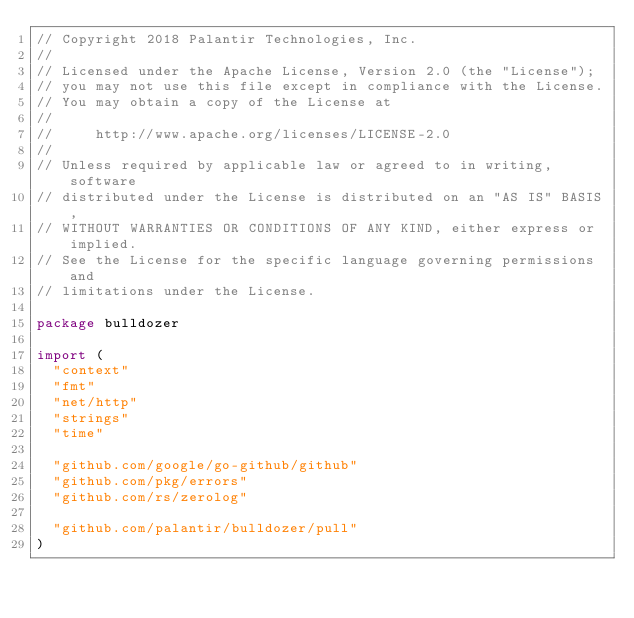<code> <loc_0><loc_0><loc_500><loc_500><_Go_>// Copyright 2018 Palantir Technologies, Inc.
//
// Licensed under the Apache License, Version 2.0 (the "License");
// you may not use this file except in compliance with the License.
// You may obtain a copy of the License at
//
//     http://www.apache.org/licenses/LICENSE-2.0
//
// Unless required by applicable law or agreed to in writing, software
// distributed under the License is distributed on an "AS IS" BASIS,
// WITHOUT WARRANTIES OR CONDITIONS OF ANY KIND, either express or implied.
// See the License for the specific language governing permissions and
// limitations under the License.

package bulldozer

import (
	"context"
	"fmt"
	"net/http"
	"strings"
	"time"

	"github.com/google/go-github/github"
	"github.com/pkg/errors"
	"github.com/rs/zerolog"

	"github.com/palantir/bulldozer/pull"
)
</code> 